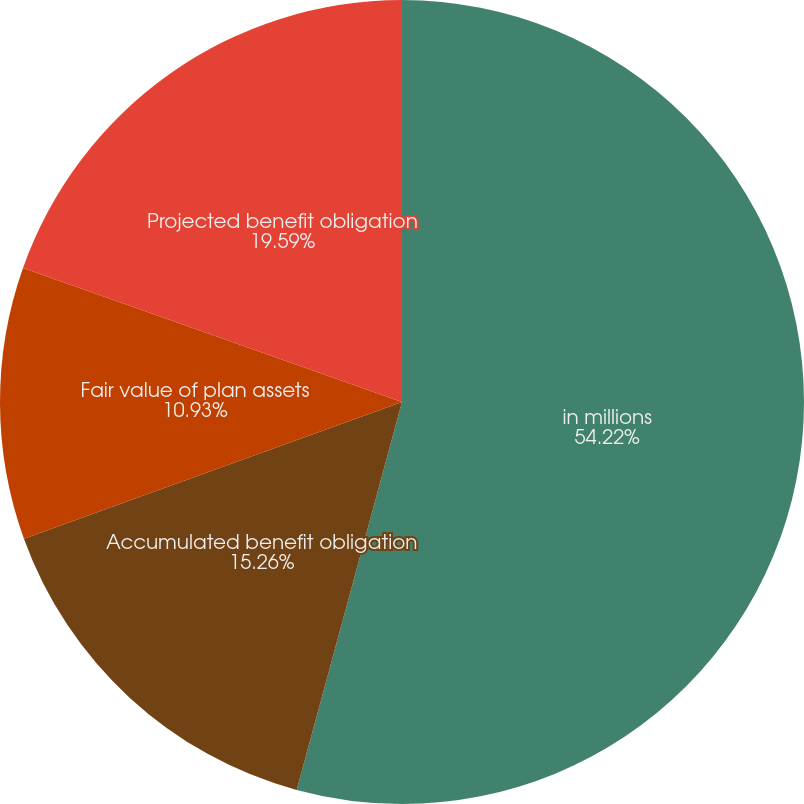Convert chart. <chart><loc_0><loc_0><loc_500><loc_500><pie_chart><fcel>in millions<fcel>Accumulated benefit obligation<fcel>Fair value of plan assets<fcel>Projected benefit obligation<nl><fcel>54.22%<fcel>15.26%<fcel>10.93%<fcel>19.59%<nl></chart> 